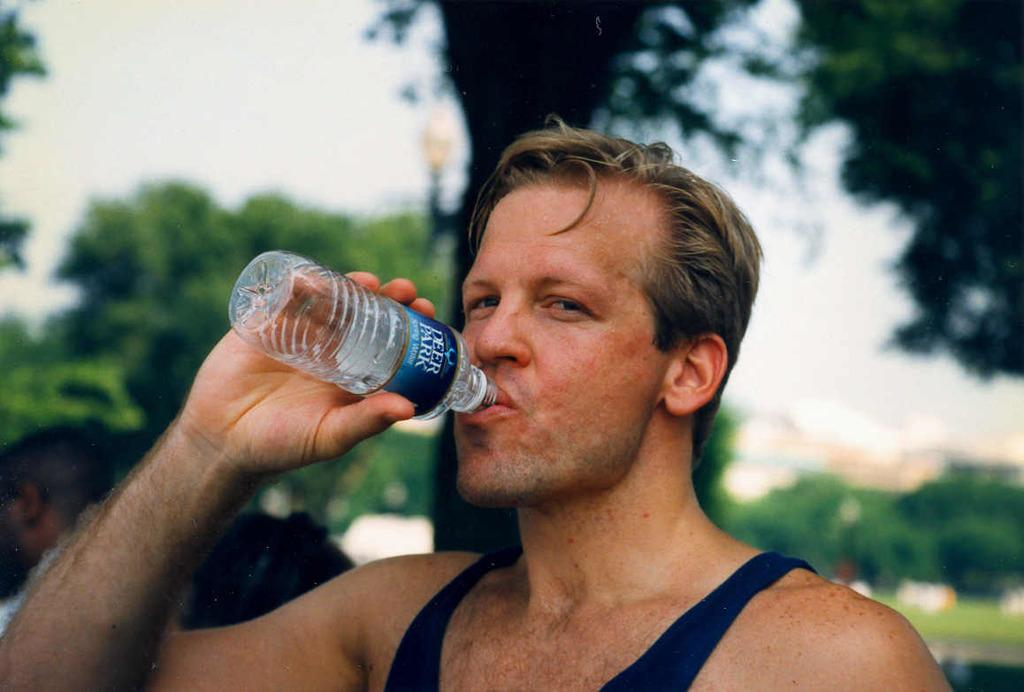Who is present in the image? There is a man in the image. What is the man wearing? The man is wearing a blue shirt. What is the man holding in the image? The man is holding a water bottle. What is the man doing with the water bottle? The man is drinking water. What type of vegetation can be seen in the image? There are plants and trees in the image. What type of advertisement can be seen in the image? There is no advertisement present in the image. Where is the hospital located in the image? There is no hospital present in the image. 